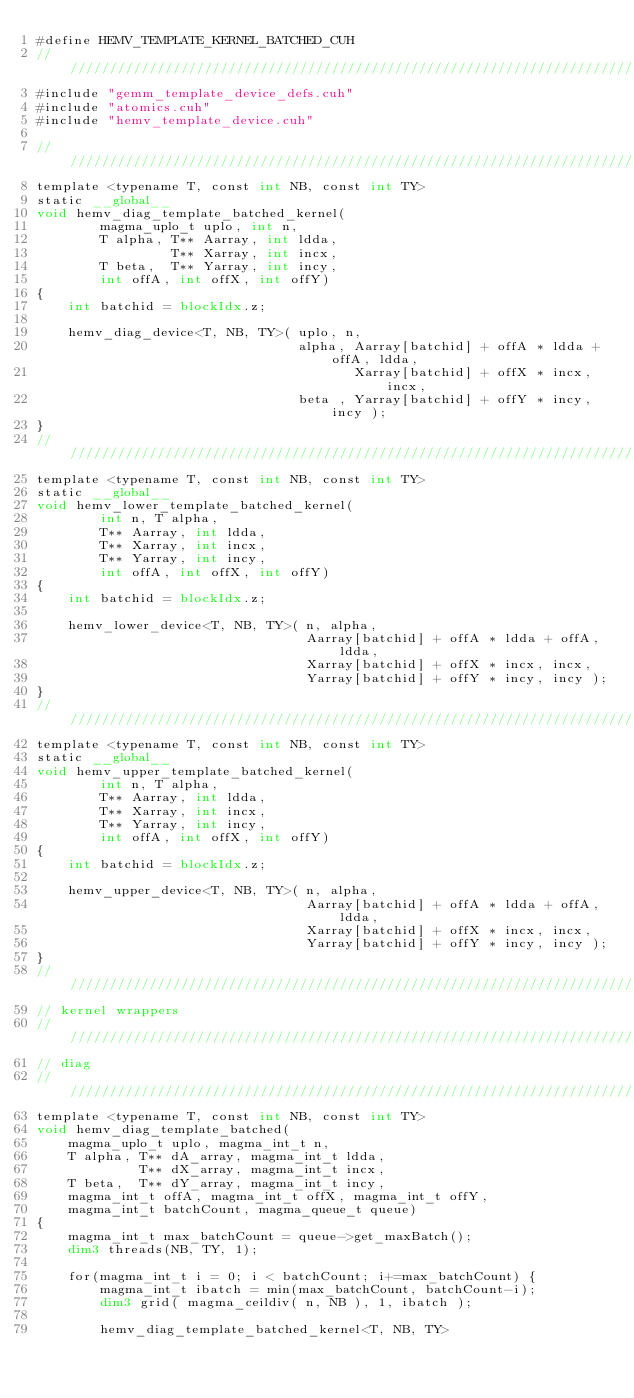<code> <loc_0><loc_0><loc_500><loc_500><_Cuda_>#define HEMV_TEMPLATE_KERNEL_BATCHED_CUH
////////////////////////////////////////////////////////////////////////////////////////////////////
#include "gemm_template_device_defs.cuh"
#include "atomics.cuh"
#include "hemv_template_device.cuh"

////////////////////////////////////////////////////////////////////////////////////////////////////
template <typename T, const int NB, const int TY>
static __global__
void hemv_diag_template_batched_kernel(
        magma_uplo_t uplo, int n,
        T alpha, T** Aarray, int ldda,
                 T** Xarray, int incx,
        T beta,  T** Yarray, int incy,
        int offA, int offX, int offY)
{
    int batchid = blockIdx.z;

    hemv_diag_device<T, NB, TY>( uplo, n,
                                 alpha, Aarray[batchid] + offA * ldda + offA, ldda,
                                        Xarray[batchid] + offX * incx, incx,
                                 beta , Yarray[batchid] + offY * incy, incy );
}
////////////////////////////////////////////////////////////////////////////////////////////////////
template <typename T, const int NB, const int TY>
static __global__
void hemv_lower_template_batched_kernel(
        int n, T alpha,
        T** Aarray, int ldda,
        T** Xarray, int incx,
        T** Yarray, int incy,
        int offA, int offX, int offY)
{
    int batchid = blockIdx.z;

    hemv_lower_device<T, NB, TY>( n, alpha,
                                  Aarray[batchid] + offA * ldda + offA, ldda,
                                  Xarray[batchid] + offX * incx, incx,
                                  Yarray[batchid] + offY * incy, incy );
}
////////////////////////////////////////////////////////////////////////////////////////////////////
template <typename T, const int NB, const int TY>
static __global__
void hemv_upper_template_batched_kernel(
        int n, T alpha,
        T** Aarray, int ldda,
        T** Xarray, int incx,
        T** Yarray, int incy,
        int offA, int offX, int offY)
{
    int batchid = blockIdx.z;

    hemv_upper_device<T, NB, TY>( n, alpha,
                                  Aarray[batchid] + offA * ldda + offA, ldda,
                                  Xarray[batchid] + offX * incx, incx,
                                  Yarray[batchid] + offY * incy, incy );
}
////////////////////////////////////////////////////////////////////////////////////////////////////
// kernel wrappers
////////////////////////////////////////////////////////////////////////////////////////////////////
// diag
////////////////////////////////////////////////////////////////////////////////////////////////////
template <typename T, const int NB, const int TY>
void hemv_diag_template_batched(
    magma_uplo_t uplo, magma_int_t n,
    T alpha, T** dA_array, magma_int_t ldda,
             T** dX_array, magma_int_t incx,
    T beta,  T** dY_array, magma_int_t incy,
    magma_int_t offA, magma_int_t offX, magma_int_t offY,
    magma_int_t batchCount, magma_queue_t queue)
{
    magma_int_t max_batchCount = queue->get_maxBatch();
    dim3 threads(NB, TY, 1);

    for(magma_int_t i = 0; i < batchCount; i+=max_batchCount) {
        magma_int_t ibatch = min(max_batchCount, batchCount-i);
        dim3 grid( magma_ceildiv( n, NB ), 1, ibatch );

        hemv_diag_template_batched_kernel<T, NB, TY></code> 